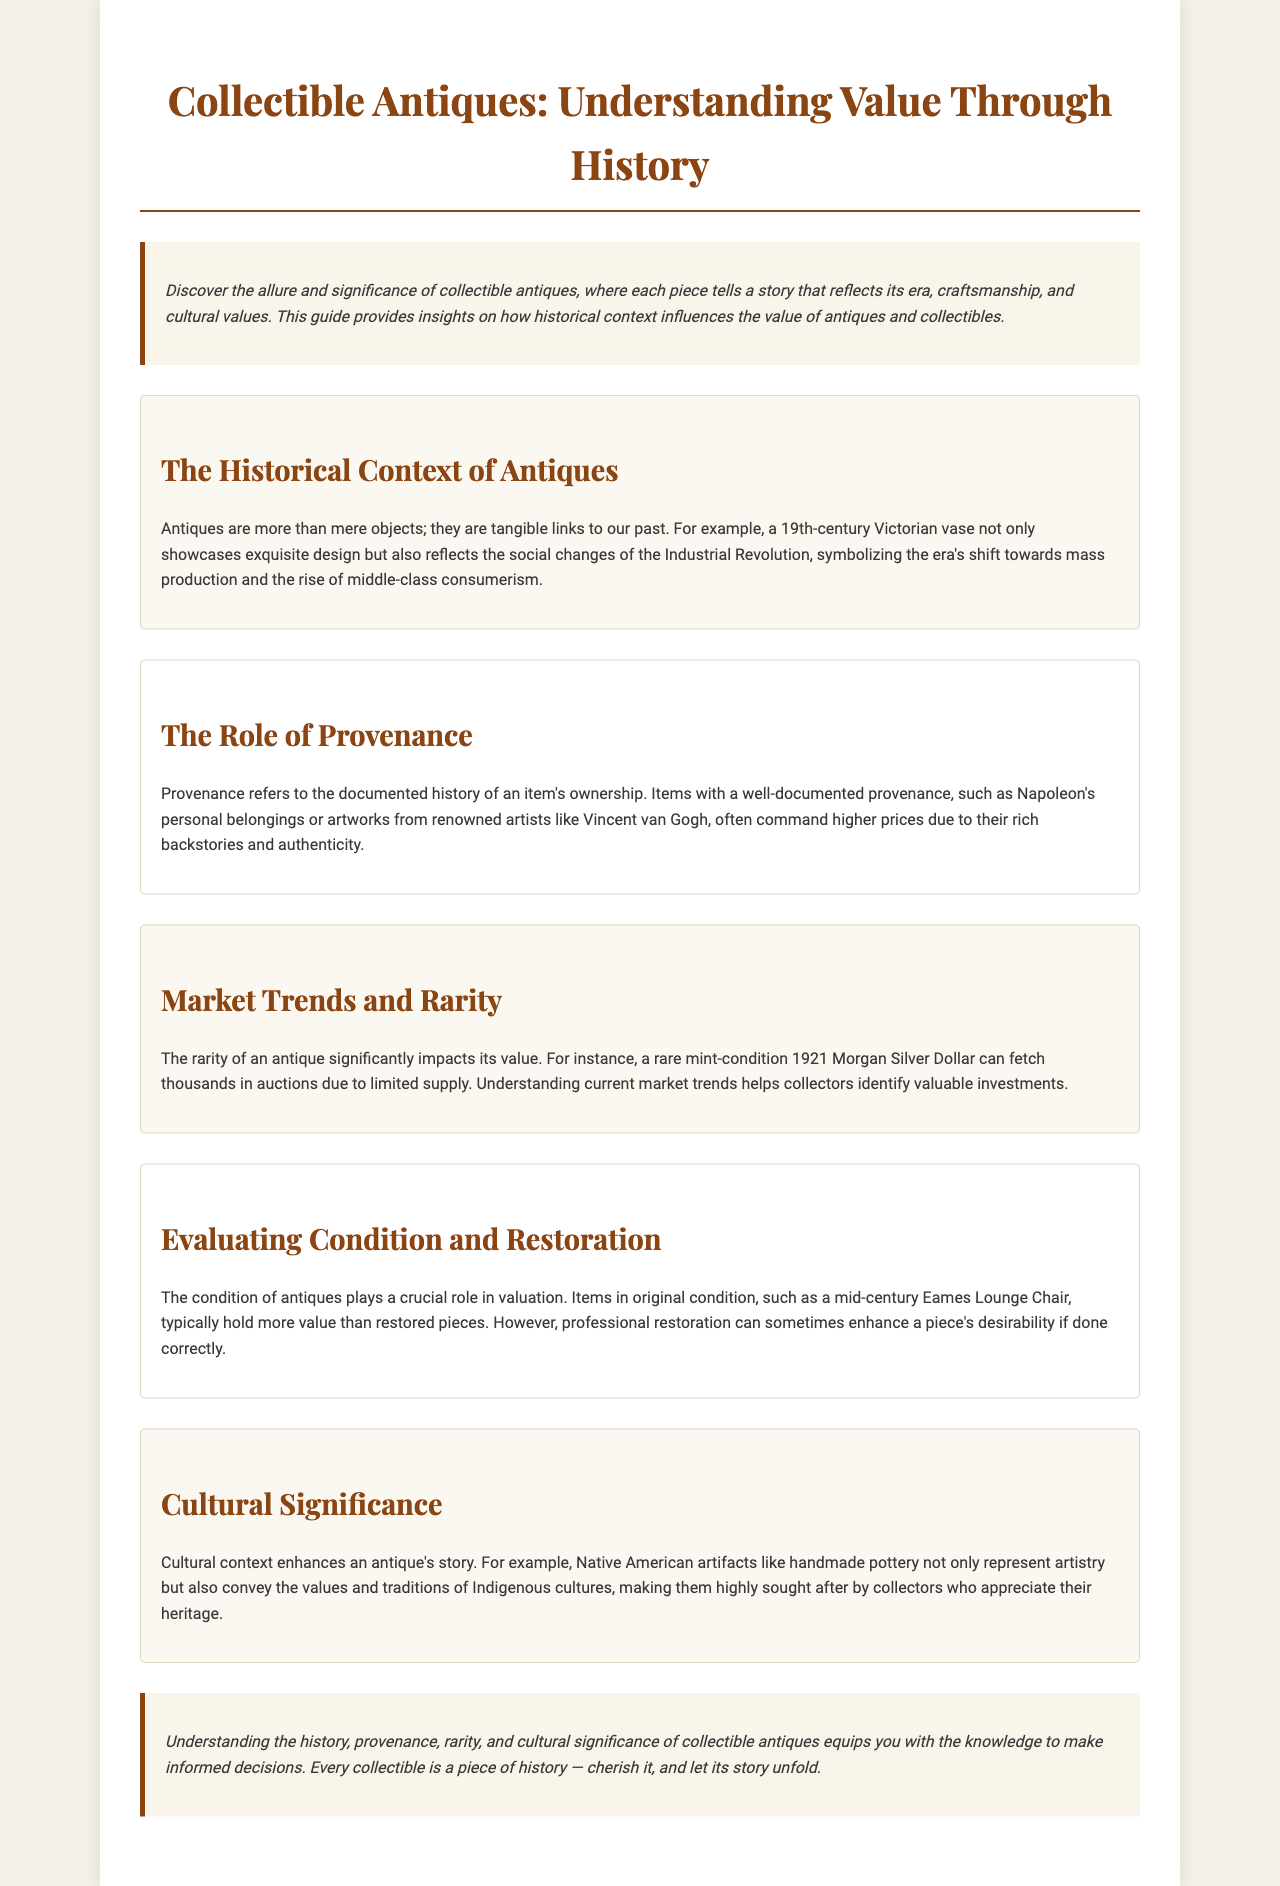what is the title of the brochure? The title is clearly stated at the top of the document.
Answer: Collectible Antiques: Understanding Value Through History what does provenance refer to? The document explains that provenance refers to the documented history of an item's ownership.
Answer: Documented history of ownership which antique is mentioned as an example of a social change during the Industrial Revolution? The section discusses a specific antique that reflects social changes in its era.
Answer: 19th-century Victorian vase what can a rare mint-condition 1921 Morgan Silver Dollar fetch? The document states that this antique can command high prices in auctions due to its rarity.
Answer: Thousands what type of artifacts represent artistry and values of Indigenous cultures? The document describes a specific category of items that are highly sought after by collectors.
Answer: Native American artifacts which mid-century item is noted for its condition impacting its value? The document mentions a specific item as an example of how condition affects valuation.
Answer: Eames Lounge Chair how does cultural significance affect the value of antiques? The document indicates that cultural context enhances an antique's story and desirability.
Answer: Enhances story what is the main purpose of this brochure? The introduction portion of the brochure states its overall goal in a concise manner.
Answer: To understand value through history 